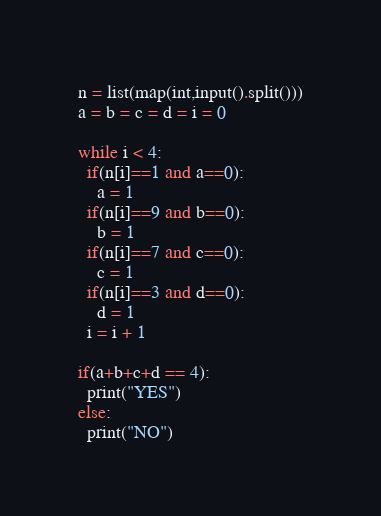Convert code to text. <code><loc_0><loc_0><loc_500><loc_500><_Python_>n = list(map(int,input().split()))
a = b = c = d = i = 0

while i < 4:
  if(n[i]==1 and a==0):
    a = 1
  if(n[i]==9 and b==0):
    b = 1
  if(n[i]==7 and c==0):
    c = 1
  if(n[i]==3 and d==0):
    d = 1
  i = i + 1
  
if(a+b+c+d == 4):
  print("YES")
else:
  print("NO")</code> 